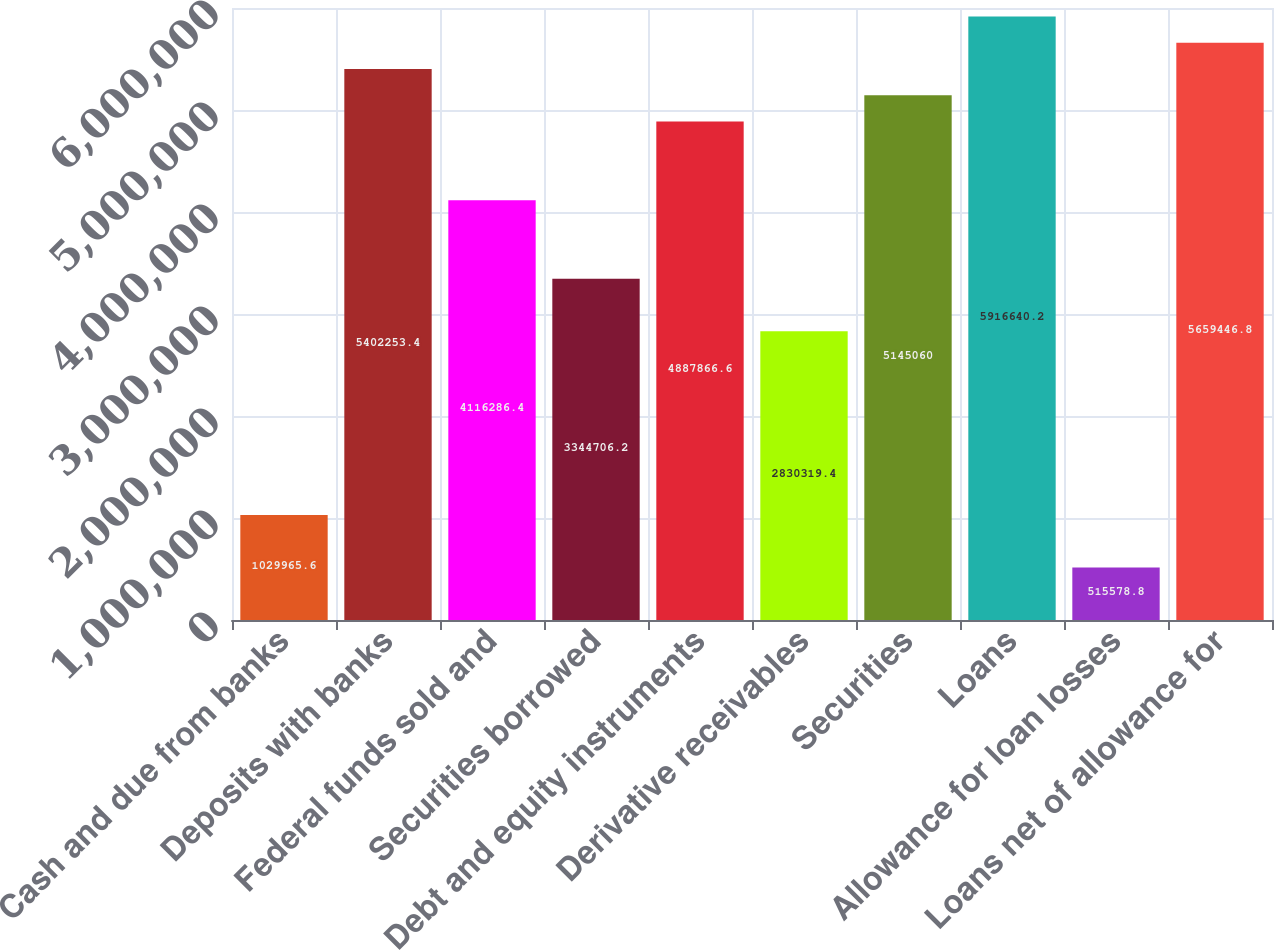Convert chart. <chart><loc_0><loc_0><loc_500><loc_500><bar_chart><fcel>Cash and due from banks<fcel>Deposits with banks<fcel>Federal funds sold and<fcel>Securities borrowed<fcel>Debt and equity instruments<fcel>Derivative receivables<fcel>Securities<fcel>Loans<fcel>Allowance for loan losses<fcel>Loans net of allowance for<nl><fcel>1.02997e+06<fcel>5.40225e+06<fcel>4.11629e+06<fcel>3.34471e+06<fcel>4.88787e+06<fcel>2.83032e+06<fcel>5.14506e+06<fcel>5.91664e+06<fcel>515579<fcel>5.65945e+06<nl></chart> 